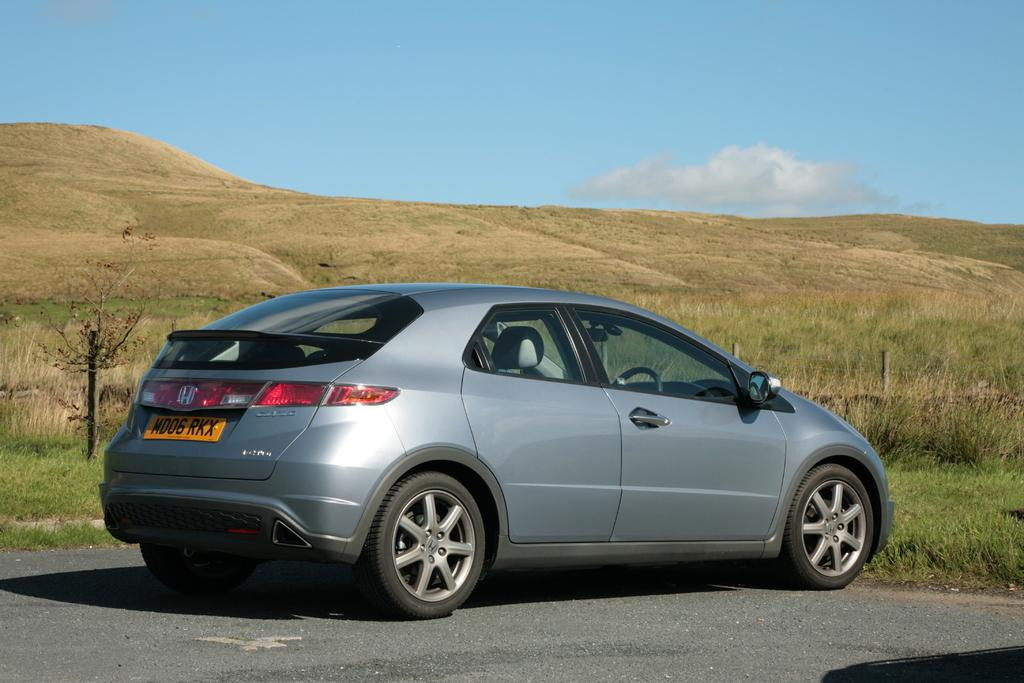What is the main subject of the image? There is a car on the road in the image. What type of vegetation can be seen in the image? There is grass visible in the image, and there is also a small tree on the left side of the image. What can be seen in the background of the image? There is a hill and the sky visible in the background of the image. How many hoses are visible in the image? There are no hoses present in the image. What does the car look like in the image? The question is too vague, as it does not specify which aspect of the car's appearance to describe. However, we can say that the car is visible on the road in the image. 